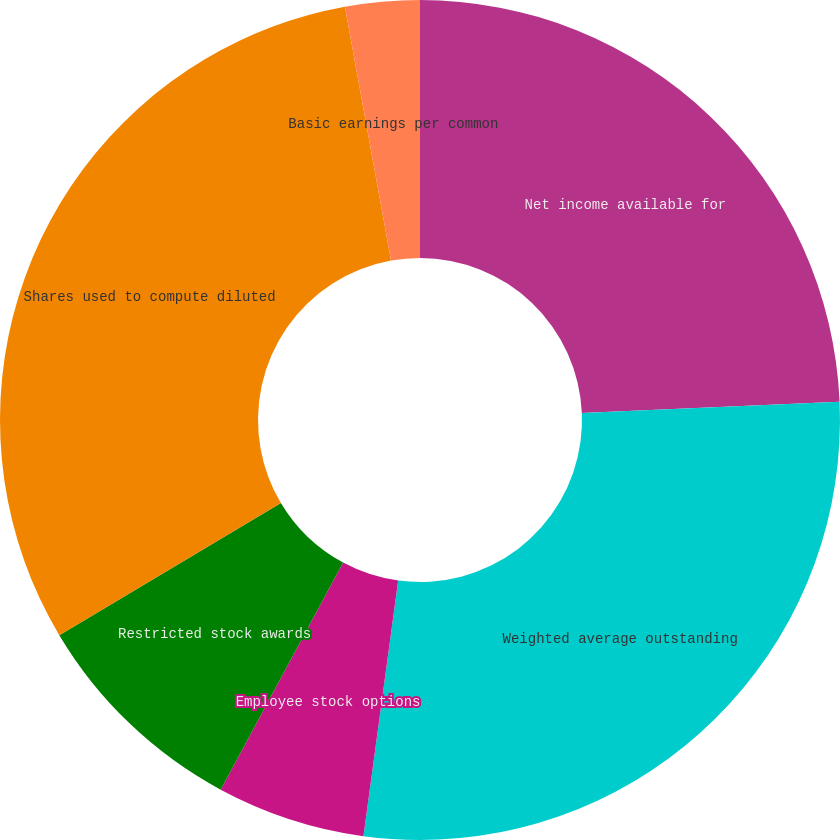Convert chart to OTSL. <chart><loc_0><loc_0><loc_500><loc_500><pie_chart><fcel>Net income available for<fcel>Weighted average outstanding<fcel>Employee stock options<fcel>Restricted stock awards<fcel>Shares used to compute diluted<fcel>Basic earnings per common<fcel>Diluted earnings per common<nl><fcel>24.31%<fcel>27.84%<fcel>5.72%<fcel>8.57%<fcel>30.7%<fcel>2.86%<fcel>0.0%<nl></chart> 